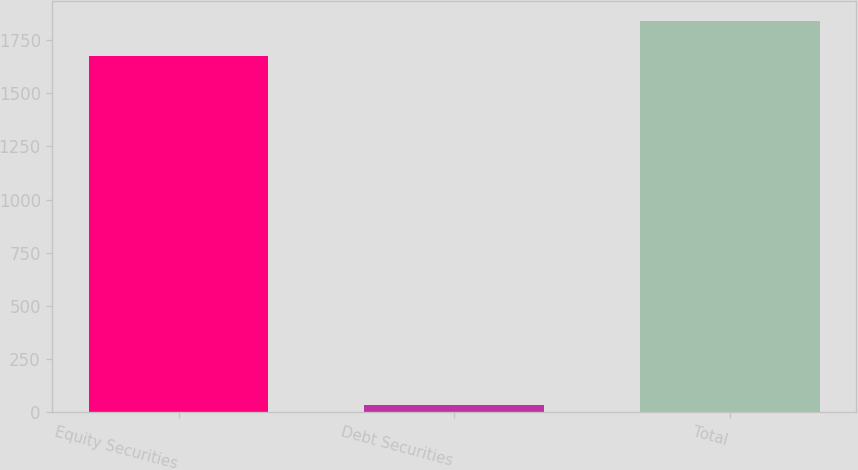<chart> <loc_0><loc_0><loc_500><loc_500><bar_chart><fcel>Equity Securities<fcel>Debt Securities<fcel>Total<nl><fcel>1673<fcel>34<fcel>1840.3<nl></chart> 